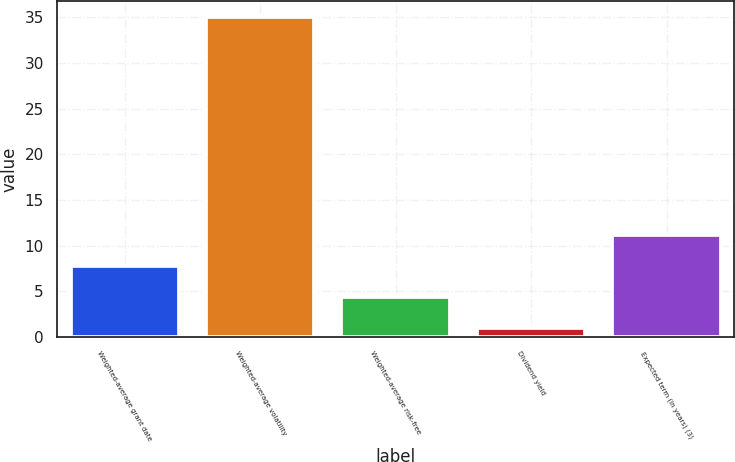Convert chart. <chart><loc_0><loc_0><loc_500><loc_500><bar_chart><fcel>Weighted-average grant date<fcel>Weighted-average volatility<fcel>Weighted-average risk-free<fcel>Dividend yield<fcel>Expected term (in years) (3)<nl><fcel>7.8<fcel>35<fcel>4.4<fcel>1<fcel>11.2<nl></chart> 